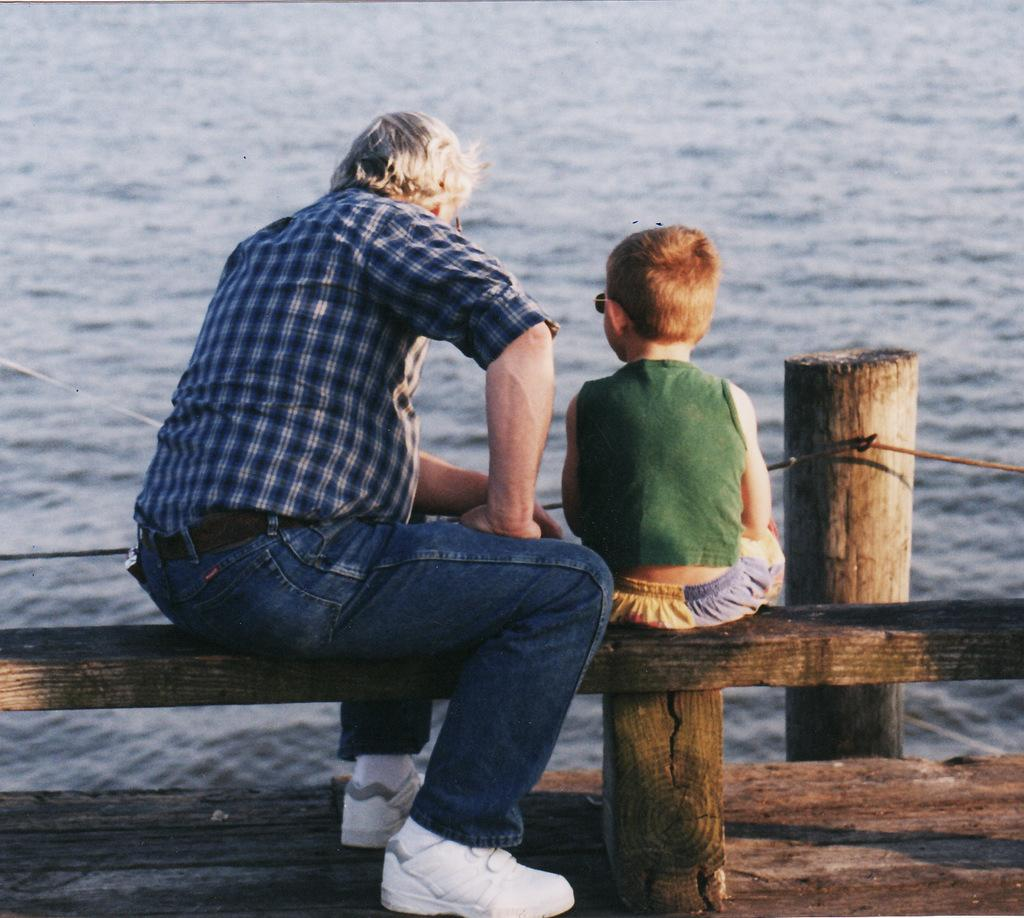Who is present in the image? There is a person and a kid in the image. What are they doing in the image? Both the person and the kid are sitting on a wooden object. What can be seen in front of them? There is water visible in front of them. What type of discussion is taking place between the person and the kid in the image? There is no indication of a discussion taking place in the image; it only shows the person and the kid sitting on a wooden object with water in front of them. 